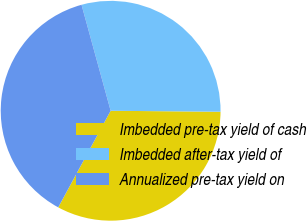Convert chart to OTSL. <chart><loc_0><loc_0><loc_500><loc_500><pie_chart><fcel>Imbedded pre-tax yield of cash<fcel>Imbedded after-tax yield of<fcel>Annualized pre-tax yield on<nl><fcel>32.77%<fcel>29.41%<fcel>37.82%<nl></chart> 